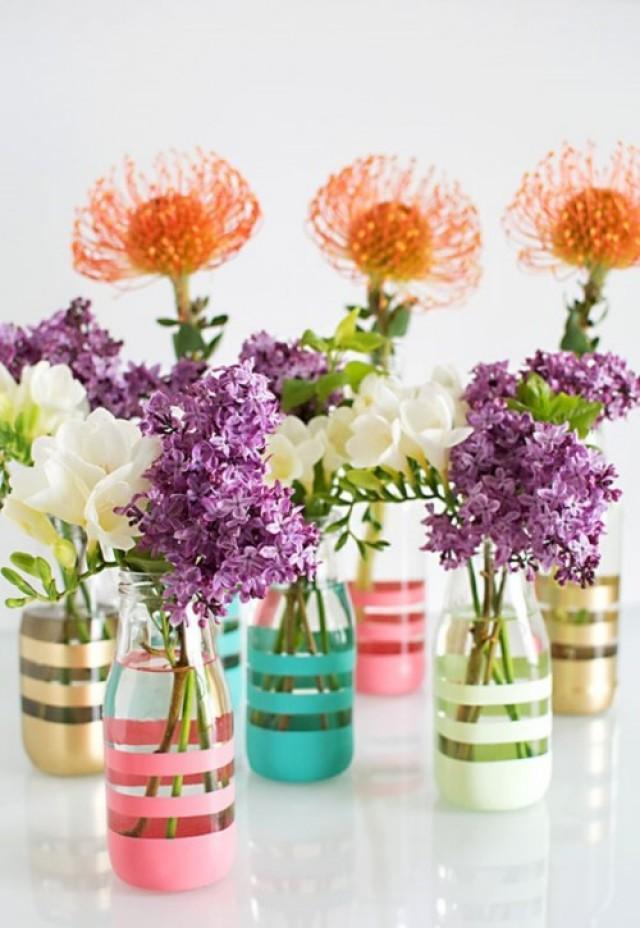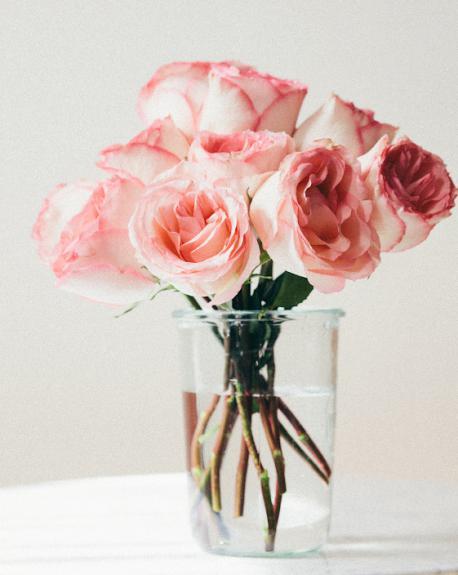The first image is the image on the left, the second image is the image on the right. Given the left and right images, does the statement "One of the images shows a vase of flowers with one single flower attached to the outside of the vase." hold true? Answer yes or no. No. The first image is the image on the left, the second image is the image on the right. For the images shown, is this caption "The left image features a clear vase containing several pink roses and one orange one, and the vase has a solid-colored flower on its front." true? Answer yes or no. No. 